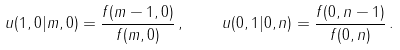<formula> <loc_0><loc_0><loc_500><loc_500>u ( 1 , 0 | m , 0 ) = \frac { f ( m - 1 , 0 ) } { f ( m , 0 ) } \, , \quad u ( 0 , 1 | 0 , n ) = \frac { f ( 0 , n - 1 ) } { f ( 0 , n ) } \, .</formula> 